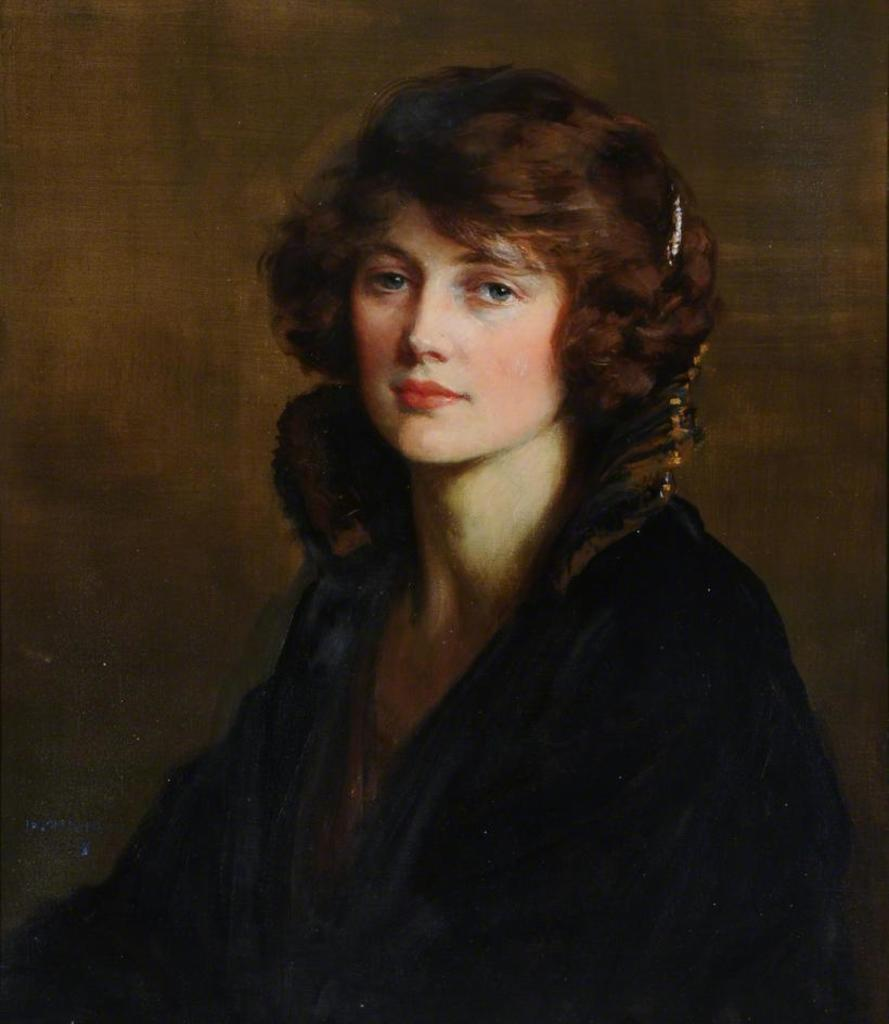What is depicted in the painting that is visible in the image? There is a painting of a woman in the image. What type of flesh can be seen on the silver skate in the image? There is no flesh, silver, or skate present in the image; it features a painting of a woman. 